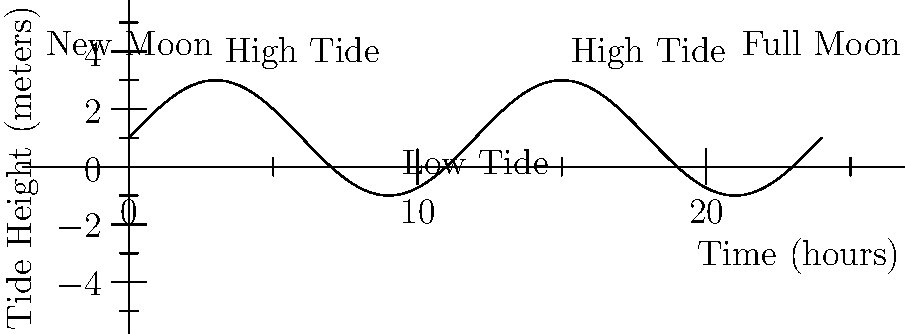Based on the tidal chart shown, which celestial body has the most significant influence on the tides, and how often do high tides occur in a 24-hour period? To answer this question, let's analyze the tidal chart step-by-step:

1. Observe the tidal pattern:
   The chart shows a sinusoidal curve repeating twice in a 24-hour period.

2. Identify high and low tides:
   There are two high tides and two low tides in the 24-hour period.

3. Consider the celestial bodies:
   The main celestial bodies influencing tides are the Moon and the Sun.

4. Analyze the Moon's influence:
   The Moon's orbital period around Earth is approximately 24 hours and 50 minutes.
   This closely matches the tidal cycle shown in the chart.

5. Compare with the Sun's influence:
   While the Sun also affects tides, its influence is less significant than the Moon's.
   The Sun's position relative to Earth doesn't change as rapidly as the Moon's.

6. Conclude the most influential celestial body:
   Based on the tidal pattern and its frequency, the Moon has the most significant influence on tides.

7. Determine the frequency of high tides:
   From the chart, we can see that high tides occur twice in the 24-hour period.

Therefore, the Moon has the most significant influence on tides, and high tides occur twice in a 24-hour period.
Answer: The Moon; twice daily 